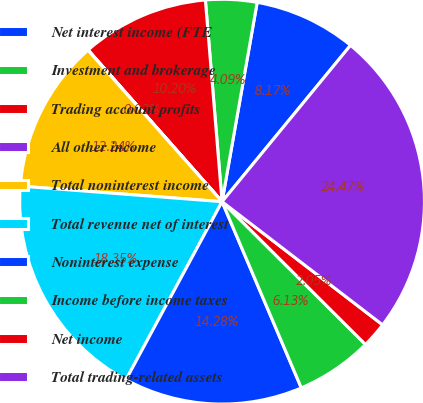Convert chart to OTSL. <chart><loc_0><loc_0><loc_500><loc_500><pie_chart><fcel>Net interest income (FTE<fcel>Investment and brokerage<fcel>Trading account profits<fcel>All other income<fcel>Total noninterest income<fcel>Total revenue net of interest<fcel>Noninterest expense<fcel>Income before income taxes<fcel>Net income<fcel>Total trading-related assets<nl><fcel>8.17%<fcel>4.09%<fcel>10.2%<fcel>0.02%<fcel>12.24%<fcel>18.35%<fcel>14.28%<fcel>6.13%<fcel>2.05%<fcel>24.47%<nl></chart> 